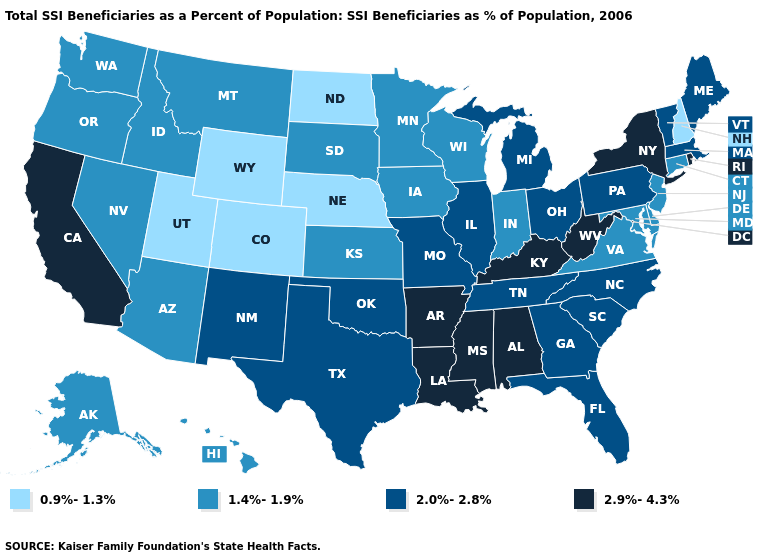Does Wyoming have a lower value than Nebraska?
Quick response, please. No. What is the highest value in the MidWest ?
Give a very brief answer. 2.0%-2.8%. What is the lowest value in the USA?
Concise answer only. 0.9%-1.3%. Among the states that border Maryland , which have the lowest value?
Answer briefly. Delaware, Virginia. What is the value of Nevada?
Quick response, please. 1.4%-1.9%. Name the states that have a value in the range 1.4%-1.9%?
Answer briefly. Alaska, Arizona, Connecticut, Delaware, Hawaii, Idaho, Indiana, Iowa, Kansas, Maryland, Minnesota, Montana, Nevada, New Jersey, Oregon, South Dakota, Virginia, Washington, Wisconsin. Is the legend a continuous bar?
Write a very short answer. No. Among the states that border Vermont , does New Hampshire have the highest value?
Be succinct. No. Name the states that have a value in the range 1.4%-1.9%?
Short answer required. Alaska, Arizona, Connecticut, Delaware, Hawaii, Idaho, Indiana, Iowa, Kansas, Maryland, Minnesota, Montana, Nevada, New Jersey, Oregon, South Dakota, Virginia, Washington, Wisconsin. Name the states that have a value in the range 2.0%-2.8%?
Answer briefly. Florida, Georgia, Illinois, Maine, Massachusetts, Michigan, Missouri, New Mexico, North Carolina, Ohio, Oklahoma, Pennsylvania, South Carolina, Tennessee, Texas, Vermont. Does Delaware have the lowest value in the South?
Be succinct. Yes. Does Arizona have a lower value than Mississippi?
Write a very short answer. Yes. Which states hav the highest value in the West?
Write a very short answer. California. What is the value of Delaware?
Short answer required. 1.4%-1.9%. What is the value of West Virginia?
Quick response, please. 2.9%-4.3%. 